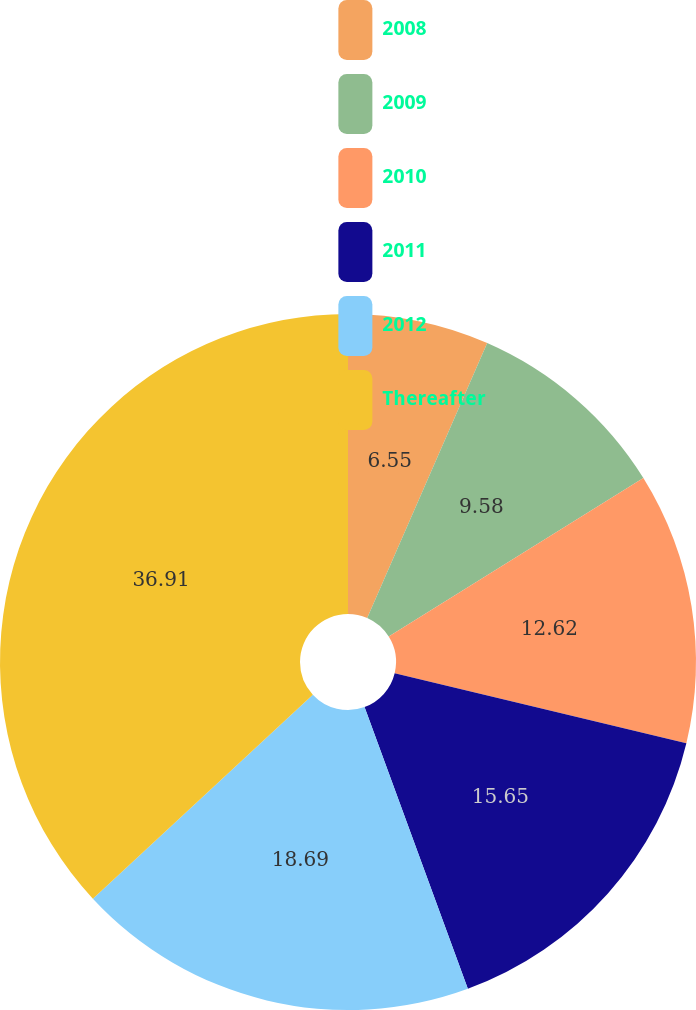<chart> <loc_0><loc_0><loc_500><loc_500><pie_chart><fcel>2008<fcel>2009<fcel>2010<fcel>2011<fcel>2012<fcel>Thereafter<nl><fcel>6.55%<fcel>9.58%<fcel>12.62%<fcel>15.65%<fcel>18.69%<fcel>36.9%<nl></chart> 